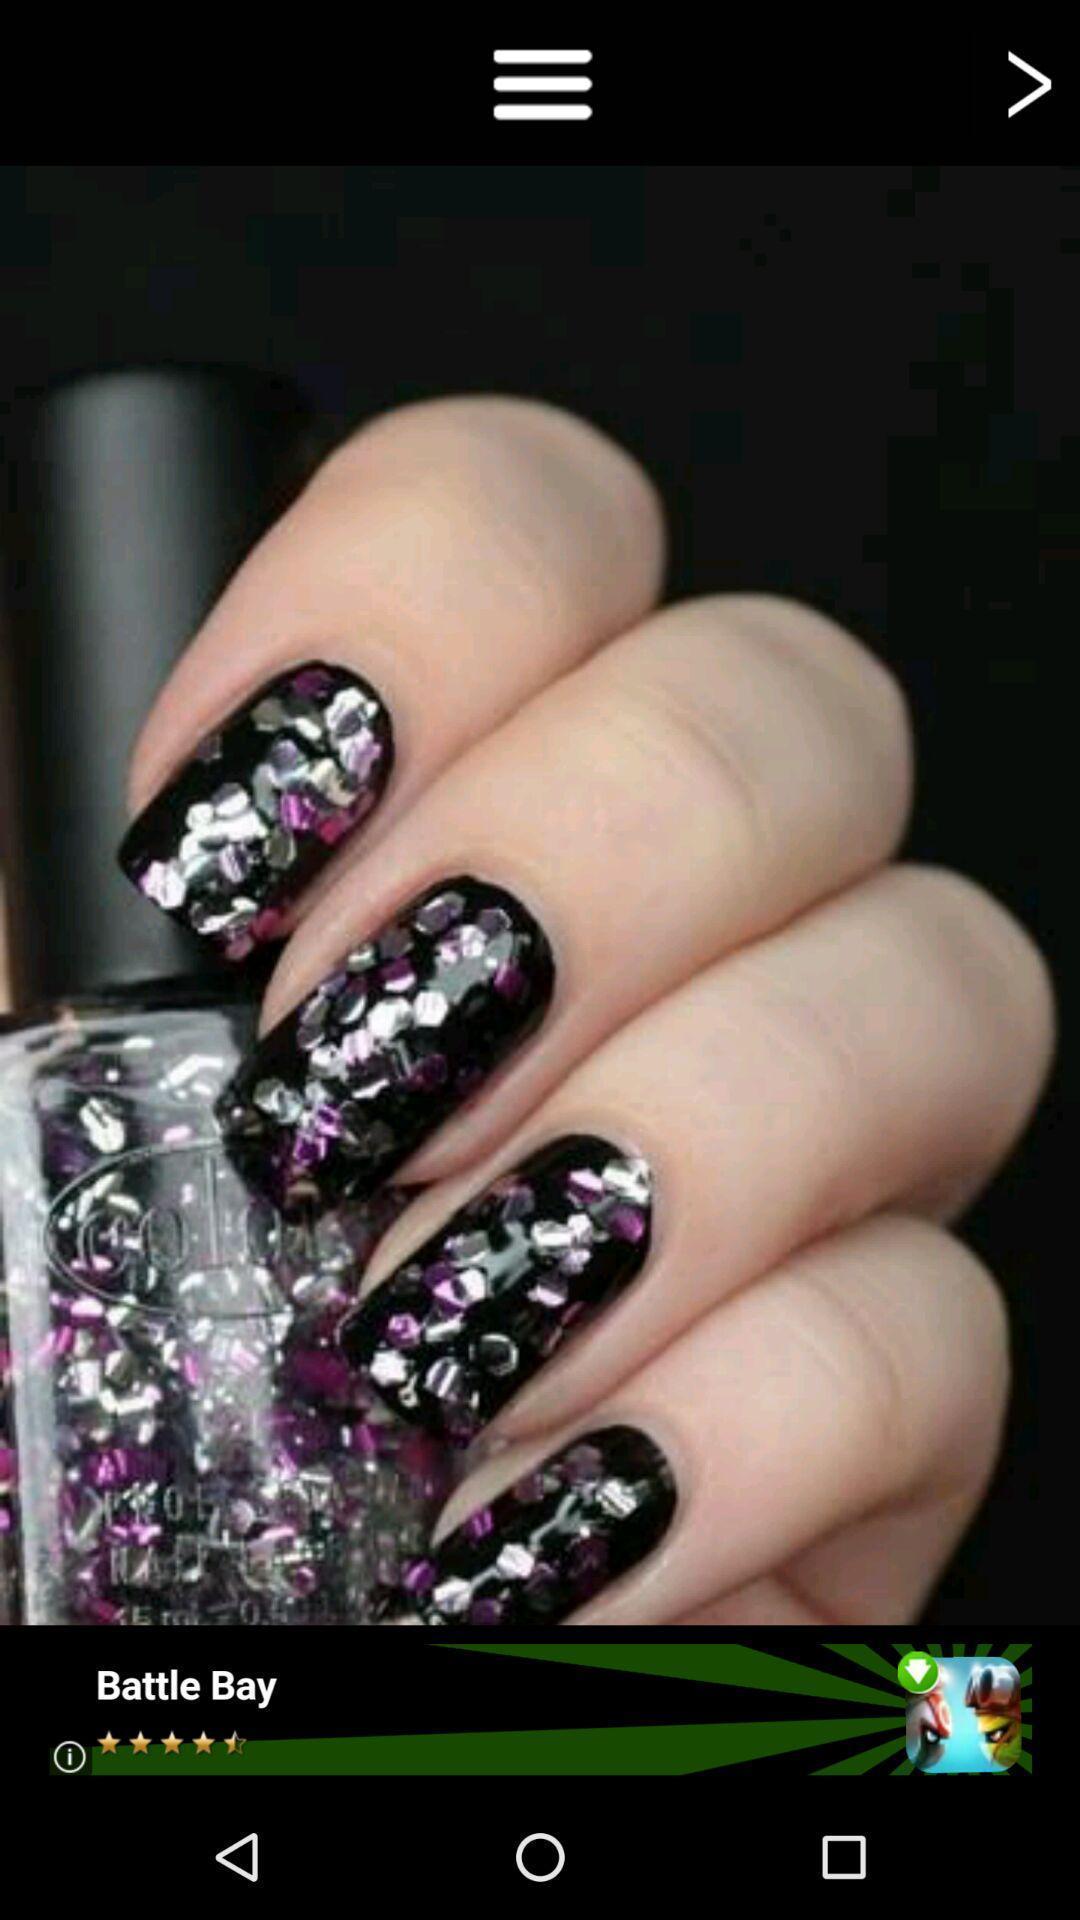Give me a summary of this screen capture. Screen show decorated nails. 